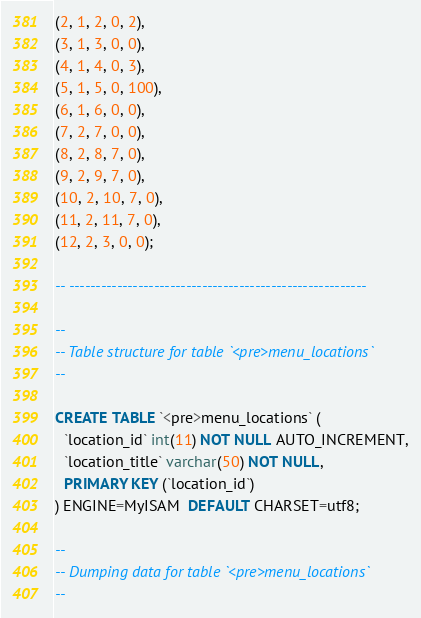Convert code to text. <code><loc_0><loc_0><loc_500><loc_500><_SQL_>(2, 1, 2, 0, 2),
(3, 1, 3, 0, 0),
(4, 1, 4, 0, 3),
(5, 1, 5, 0, 100),
(6, 1, 6, 0, 0),
(7, 2, 7, 0, 0),
(8, 2, 8, 7, 0),
(9, 2, 9, 7, 0),
(10, 2, 10, 7, 0),
(11, 2, 11, 7, 0),
(12, 2, 3, 0, 0);

-- --------------------------------------------------------

--
-- Table structure for table `<pre>menu_locations`
--

CREATE TABLE `<pre>menu_locations` (
  `location_id` int(11) NOT NULL AUTO_INCREMENT,
  `location_title` varchar(50) NOT NULL,
  PRIMARY KEY (`location_id`)
) ENGINE=MyISAM  DEFAULT CHARSET=utf8;

--
-- Dumping data for table `<pre>menu_locations`
--
</code> 